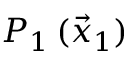Convert formula to latex. <formula><loc_0><loc_0><loc_500><loc_500>P _ { 1 } \, ( \vec { x } _ { 1 } )</formula> 